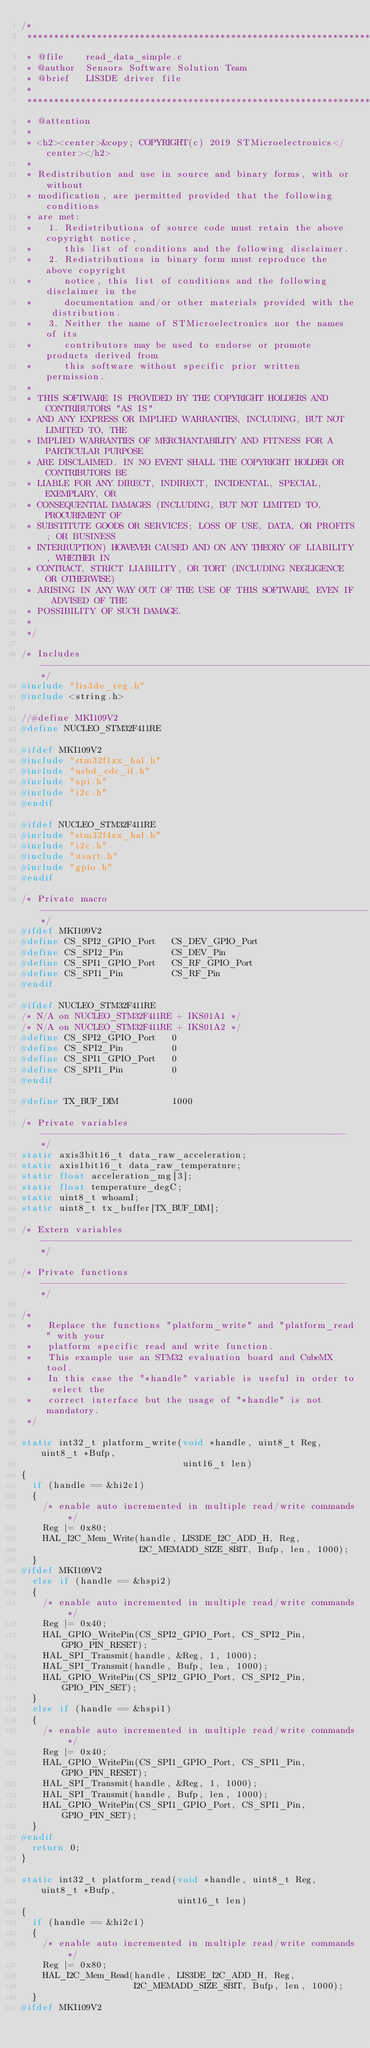Convert code to text. <code><loc_0><loc_0><loc_500><loc_500><_C_>/*
 ******************************************************************************
 * @file    read_data_simple.c
 * @author  Sensors Software Solution Team
 * @brief   LIS3DE driver file
 *
 ******************************************************************************
 * @attention
 *
 * <h2><center>&copy; COPYRIGHT(c) 2019 STMicroelectronics</center></h2>
 *
 * Redistribution and use in source and binary forms, with or without
 * modification, are permitted provided that the following conditions
 * are met:
 *   1. Redistributions of source code must retain the above copyright notice,
 *      this list of conditions and the following disclaimer.
 *   2. Redistributions in binary form must reproduce the above copyright
 *      notice, this list of conditions and the following disclaimer in the
 *      documentation and/or other materials provided with the distribution.
 *   3. Neither the name of STMicroelectronics nor the names of its
 *      contributors may be used to endorse or promote products derived from
 *      this software without specific prior written permission.
 *
 * THIS SOFTWARE IS PROVIDED BY THE COPYRIGHT HOLDERS AND CONTRIBUTORS "AS IS"
 * AND ANY EXPRESS OR IMPLIED WARRANTIES, INCLUDING, BUT NOT LIMITED TO, THE
 * IMPLIED WARRANTIES OF MERCHANTABILITY AND FITNESS FOR A PARTICULAR PURPOSE
 * ARE DISCLAIMED. IN NO EVENT SHALL THE COPYRIGHT HOLDER OR CONTRIBUTORS BE
 * LIABLE FOR ANY DIRECT, INDIRECT, INCIDENTAL, SPECIAL, EXEMPLARY, OR
 * CONSEQUENTIAL DAMAGES (INCLUDING, BUT NOT LIMITED TO, PROCUREMENT OF
 * SUBSTITUTE GOODS OR SERVICES; LOSS OF USE, DATA, OR PROFITS; OR BUSINESS
 * INTERRUPTION) HOWEVER CAUSED AND ON ANY THEORY OF LIABILITY, WHETHER IN
 * CONTRACT, STRICT LIABILITY, OR TORT (INCLUDING NEGLIGENCE OR OTHERWISE)
 * ARISING IN ANY WAY OUT OF THE USE OF THIS SOFTWARE, EVEN IF ADVISED OF THE
 * POSSIBILITY OF SUCH DAMAGE.
 *
 */

/* Includes ------------------------------------------------------------------*/
#include "lis3de_reg.h"
#include <string.h>

//#define MKI109V2
#define NUCLEO_STM32F411RE

#ifdef MKI109V2
#include "stm32f1xx_hal.h"
#include "usbd_cdc_if.h"
#include "spi.h"
#include "i2c.h"
#endif

#ifdef NUCLEO_STM32F411RE
#include "stm32f4xx_hal.h"
#include "i2c.h"
#include "usart.h"
#include "gpio.h"
#endif

/* Private macro -------------------------------------------------------------*/
#ifdef MKI109V2
#define CS_SPI2_GPIO_Port   CS_DEV_GPIO_Port
#define CS_SPI2_Pin         CS_DEV_Pin
#define CS_SPI1_GPIO_Port   CS_RF_GPIO_Port
#define CS_SPI1_Pin         CS_RF_Pin
#endif

#ifdef NUCLEO_STM32F411RE
/* N/A on NUCLEO_STM32F411RE + IKS01A1 */
/* N/A on NUCLEO_STM32F411RE + IKS01A2 */
#define CS_SPI2_GPIO_Port   0
#define CS_SPI2_Pin         0
#define CS_SPI1_GPIO_Port   0
#define CS_SPI1_Pin         0
#endif

#define TX_BUF_DIM          1000

/* Private variables ---------------------------------------------------------*/
static axis3bit16_t data_raw_acceleration;
static axis1bit16_t data_raw_temperature;
static float acceleration_mg[3];
static float temperature_degC;
static uint8_t whoamI;
static uint8_t tx_buffer[TX_BUF_DIM];

/* Extern variables ----------------------------------------------------------*/

/* Private functions ---------------------------------------------------------*/

/*
 *   Replace the functions "platform_write" and "platform_read" with your
 *   platform specific read and write function.
 *   This example use an STM32 evaluation board and CubeMX tool.
 *   In this case the "*handle" variable is useful in order to select the
 *   correct interface but the usage of "*handle" is not mandatory.
 */

static int32_t platform_write(void *handle, uint8_t Reg, uint8_t *Bufp,
                              uint16_t len)
{
  if (handle == &hi2c1)
  {
    /* enable auto incremented in multiple read/write commands */
    Reg |= 0x80; 
    HAL_I2C_Mem_Write(handle, LIS3DE_I2C_ADD_H, Reg,
                      I2C_MEMADD_SIZE_8BIT, Bufp, len, 1000);
  }
#ifdef MKI109V2  
  else if (handle == &hspi2)
  {
    /* enable auto incremented in multiple read/write commands */
    Reg |= 0x40;    
    HAL_GPIO_WritePin(CS_SPI2_GPIO_Port, CS_SPI2_Pin, GPIO_PIN_RESET);
    HAL_SPI_Transmit(handle, &Reg, 1, 1000);
    HAL_SPI_Transmit(handle, Bufp, len, 1000);
    HAL_GPIO_WritePin(CS_SPI2_GPIO_Port, CS_SPI2_Pin, GPIO_PIN_SET);
  }
  else if (handle == &hspi1)
  {
    /* enable auto incremented in multiple read/write commands */
    Reg |= 0x40;     
    HAL_GPIO_WritePin(CS_SPI1_GPIO_Port, CS_SPI1_Pin, GPIO_PIN_RESET);
    HAL_SPI_Transmit(handle, &Reg, 1, 1000);
    HAL_SPI_Transmit(handle, Bufp, len, 1000);
    HAL_GPIO_WritePin(CS_SPI1_GPIO_Port, CS_SPI1_Pin, GPIO_PIN_SET);
  }
#endif
  return 0;
}

static int32_t platform_read(void *handle, uint8_t Reg, uint8_t *Bufp,
                             uint16_t len)
{
  if (handle == &hi2c1)
  {
    /* enable auto incremented in multiple read/write commands */
    Reg |= 0x80;
    HAL_I2C_Mem_Read(handle, LIS3DE_I2C_ADD_H, Reg,
                     I2C_MEMADD_SIZE_8BIT, Bufp, len, 1000);
  }
#ifdef MKI109V2   </code> 